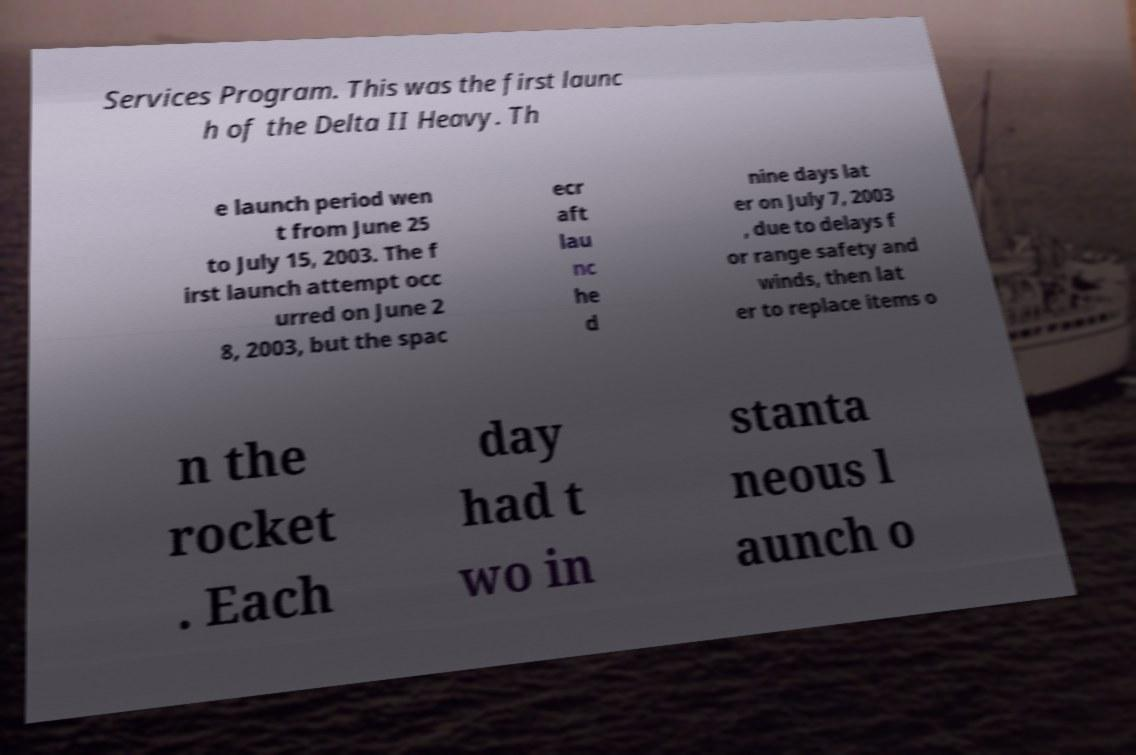Please read and relay the text visible in this image. What does it say? Services Program. This was the first launc h of the Delta II Heavy. Th e launch period wen t from June 25 to July 15, 2003. The f irst launch attempt occ urred on June 2 8, 2003, but the spac ecr aft lau nc he d nine days lat er on July 7, 2003 , due to delays f or range safety and winds, then lat er to replace items o n the rocket . Each day had t wo in stanta neous l aunch o 